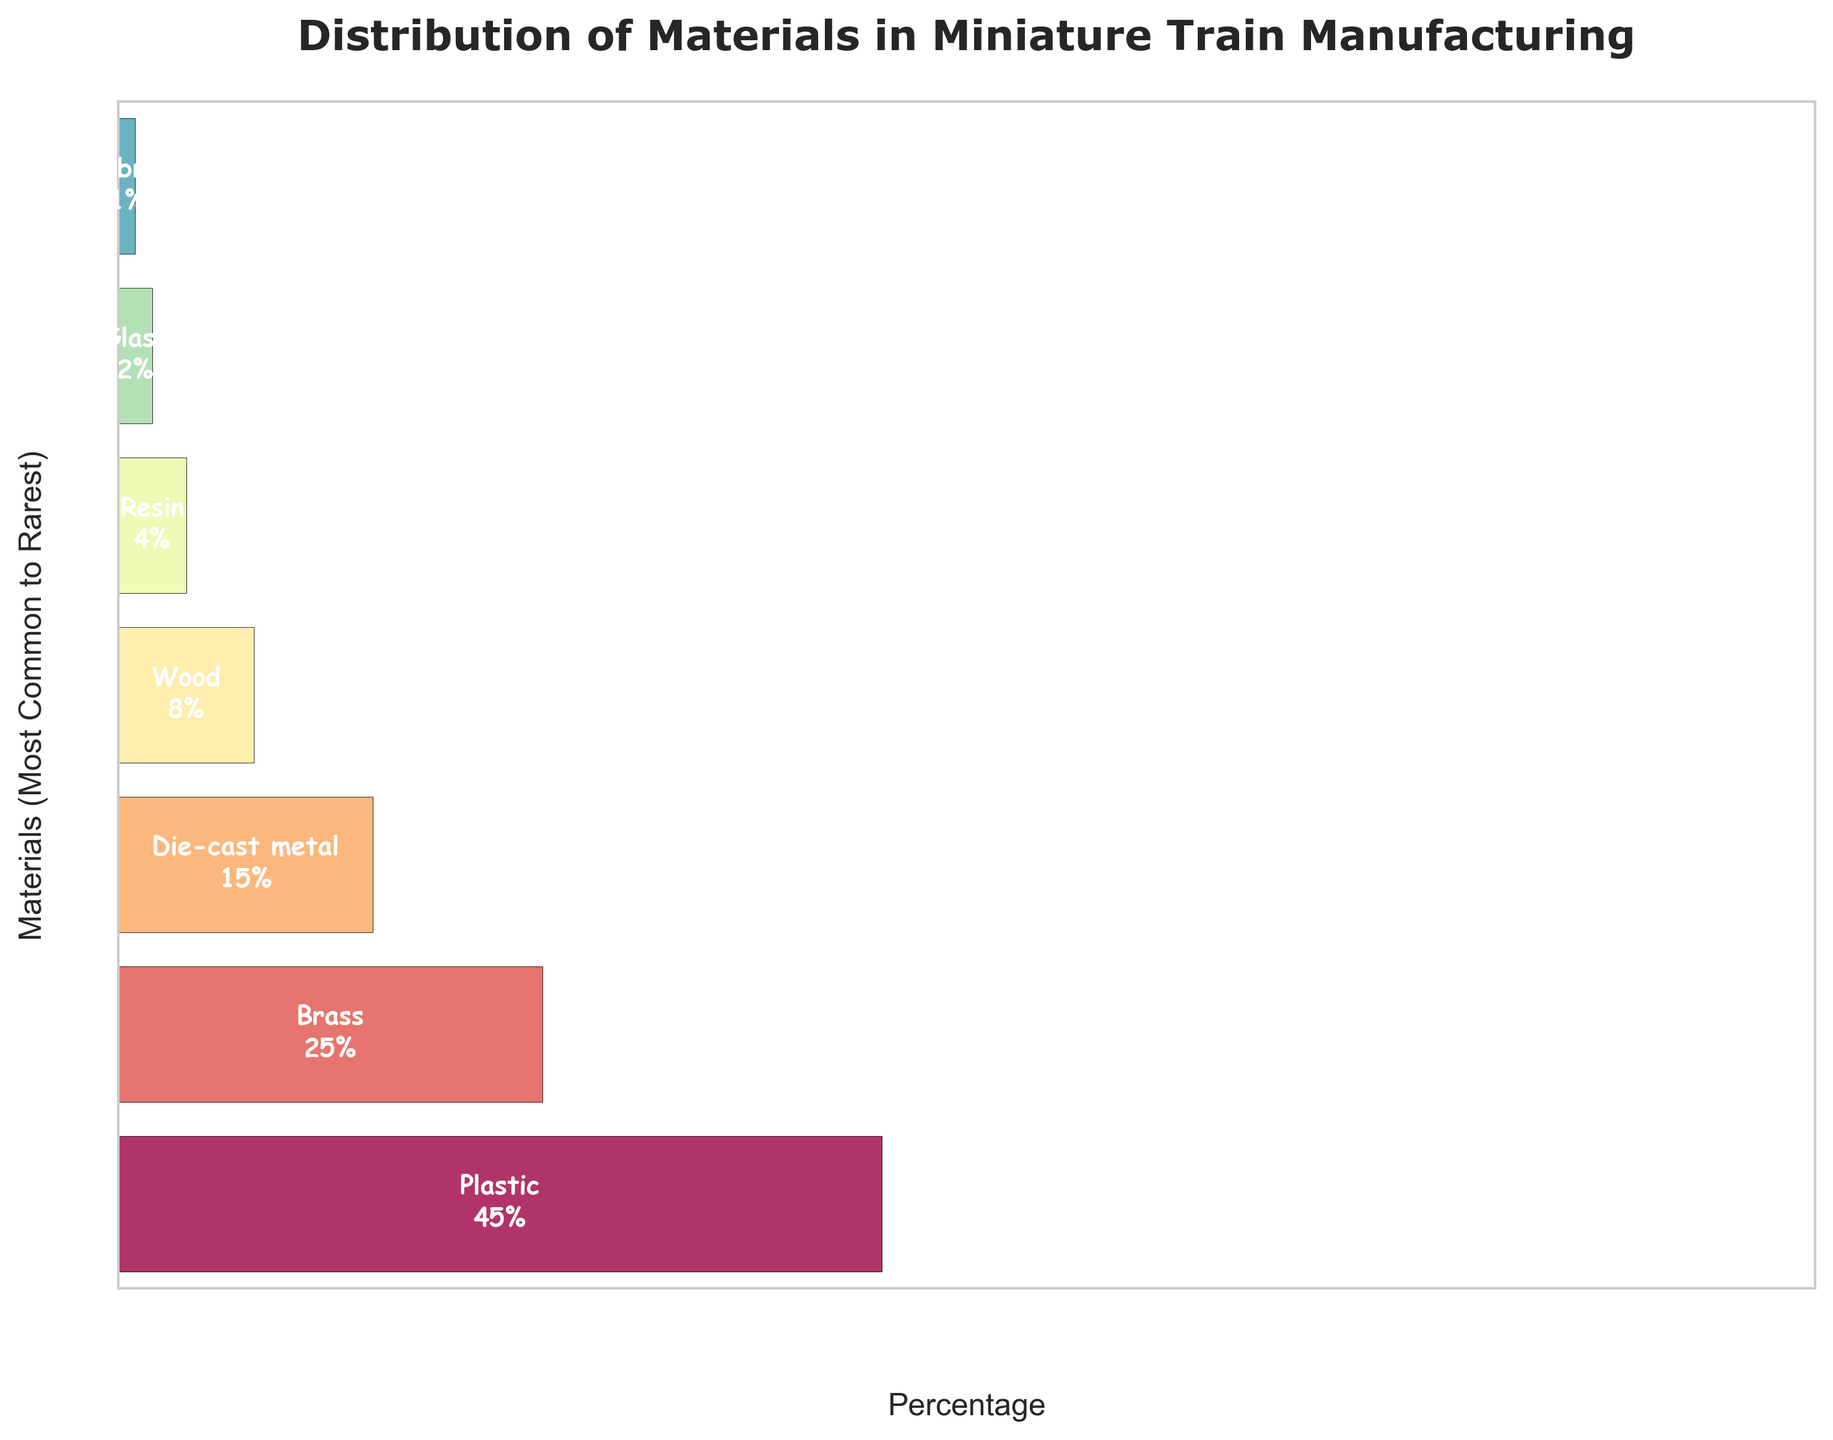what is the title of the funnel chart? The chart has a title at the top. By reading the title, you know the chart is about the "Distribution of Materials in Miniature Train Manufacturing"
Answer: Distribution of Materials in Miniature Train Manufacturing Which material is used the most in miniature train manufacturing? The widest bar at the top represents the most commonly used material in miniature train manufacturing. By looking at this, you can see it is "Plastic" with 45%.
Answer: Plastic What is the percentage of brass used? The percentage of brass used is listed in the chart next to the corresponding bar segment. By locating brass, you see the percentage listed.
Answer: 25% What materials constitute less than 10% of the composition? By examining the bars and their percentages, identify which materials have values under 10%. These are wood (8%), resin (4%), glass (2%), and fabric (1%).
Answer: Wood, Resin, Glass, Fabric What is the cumulative percentage of Plastic, Brass, and Die-cast metal? Add the percentages of Plastic (45%), Brass (25%), and Die-cast metal (15%) together: 45 + 25 + 15.
Answer: 85% How much more Plastic than Resin is used in the manufacturing process? Subtract the percentage of Resin (4%) from the percentage of Plastic (45%): 45 - 4.
Answer: 41% Which is rarer, Glass or Fabric? Compare the percentages of Glass (2%) and Fabric (1%); Fabric has a smaller percentage.
Answer: Fabric What is the difference in percentage between the most common and the rarest materials? Subtract the percentage of the rarest material (Fabric, 1%) from the percentage of the most common material (Plastic, 45%) to get the difference: 45 - 1.
Answer: 44% How do the combined percentages of Die-cast metal and Wood compare to Brass percentage? Add the percentages of Die-cast metal (15%) and Wood (8%), then compare it to the percentage of Brass (25%). The sum of Die-cast metal and Wood is 15 + 8 = 23, which is less than 25.
Answer: Less Which material forms the third-largest percentage of the manufacturing composition? Check the sizes of the bars and locate the third largest. The third largest percentage is Die-cast metal, with 15%.
Answer: Die-cast metal 